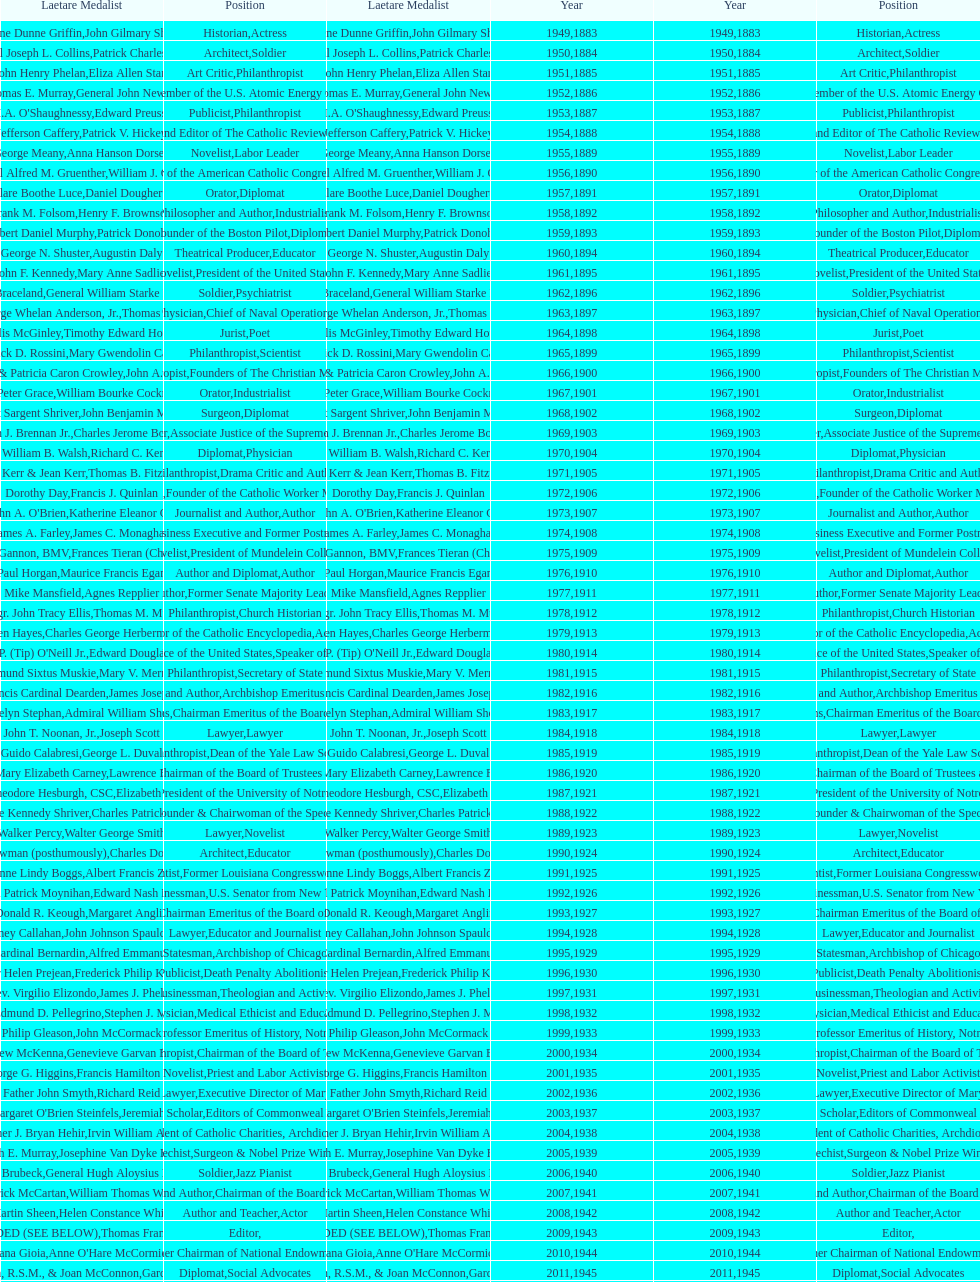Can you parse all the data within this table? {'header': ['Laetare Medalist', 'Position', 'Laetare Medalist', 'Year', 'Year', 'Position'], 'rows': [['Irene Dunne Griffin', 'Historian', 'John Gilmary Shea', '1949', '1883', 'Actress'], ['General Joseph L. Collins', 'Architect', 'Patrick Charles Keely', '1950', '1884', 'Soldier'], ['John Henry Phelan', 'Art Critic', 'Eliza Allen Starr', '1951', '1885', 'Philanthropist'], ['Thomas E. Murray', 'Engineer', 'General John Newton', '1952', '1886', 'Member of the U.S. Atomic Energy Commission'], ["I.A. O'Shaughnessy", 'Publicist', 'Edward Preuss', '1953', '1887', 'Philanthropist'], ['Jefferson Caffery', 'Founder and Editor of The Catholic Review', 'Patrick V. Hickey', '1954', '1888', 'Diplomat'], ['George Meany', 'Novelist', 'Anna Hanson Dorsey', '1955', '1889', 'Labor Leader'], ['General Alfred M. Gruenther', 'Organizer of the American Catholic Congress', 'William J. Onahan', '1956', '1890', 'Soldier'], ['Clare Boothe Luce', 'Orator', 'Daniel Dougherty', '1957', '1891', 'Diplomat'], ['Frank M. Folsom', 'Philosopher and Author', 'Henry F. Brownson', '1958', '1892', 'Industrialist'], ['Robert Daniel Murphy', 'Founder of the Boston Pilot', 'Patrick Donohue', '1959', '1893', 'Diplomat'], ['George N. Shuster', 'Theatrical Producer', 'Augustin Daly', '1960', '1894', 'Educator'], ['John F. Kennedy', 'Novelist', 'Mary Anne Sadlier', '1961', '1895', 'President of the United States'], ['Francis J. Braceland', 'Soldier', 'General William Starke Rosencrans', '1962', '1896', 'Psychiatrist'], ['Admiral George Whelan Anderson, Jr.', 'Physician', 'Thomas Addis Emmet', '1963', '1897', 'Chief of Naval Operations'], ['Phyllis McGinley', 'Jurist', 'Timothy Edward Howard', '1964', '1898', 'Poet'], ['Frederick D. Rossini', 'Philanthropist', 'Mary Gwendolin Caldwell', '1965', '1899', 'Scientist'], ['Patrick F. & Patricia Caron Crowley', 'Philanthropist', 'John A. Creighton', '1966', '1900', 'Founders of The Christian Movement'], ['J. Peter Grace', 'Orator', 'William Bourke Cockran', '1967', '1901', 'Industrialist'], ['Robert Sargent Shriver', 'Surgeon', 'John Benjamin Murphy', '1968', '1902', 'Diplomat'], ['William J. Brennan Jr.', 'Lawyer', 'Charles Jerome Bonaparte', '1969', '1903', 'Associate Justice of the Supreme Court'], ['Dr. William B. Walsh', 'Diplomat', 'Richard C. Kerens', '1970', '1904', 'Physician'], ['Walter Kerr & Jean Kerr', 'Philanthropist', 'Thomas B. Fitzpatrick', '1971', '1905', 'Drama Critic and Author'], ['Dorothy Day', 'Physician', 'Francis J. Quinlan', '1972', '1906', 'Founder of the Catholic Worker Movement'], ["Rev. John A. O'Brien", 'Journalist and Author', 'Katherine Eleanor Conway', '1973', '1907', 'Author'], ['James A. Farley', 'Economist', 'James C. Monaghan', '1974', '1908', 'Business Executive and Former Postmaster General'], ['Sr. Ann Ida Gannon, BMV', 'Novelist', 'Frances Tieran (Christian Reid)', '1975', '1909', 'President of Mundelein College'], ['Paul Horgan', 'Author and Diplomat', 'Maurice Francis Egan', '1976', '1910', 'Author'], ['Mike Mansfield', 'Author', 'Agnes Repplier', '1977', '1911', 'Former Senate Majority Leader'], ['Msgr. John Tracy Ellis', 'Philanthropist', 'Thomas M. Mulry', '1978', '1912', 'Church Historian'], ['Helen Hayes', 'Editor of the Catholic Encyclopedia', 'Charles George Herbermann', '1979', '1913', 'Actress'], ["Thomas P. (Tip) O'Neill Jr.", 'Chief Justice of the United States', 'Edward Douglass White', '1980', '1914', 'Speaker of the House'], ['Edmund Sixtus Muskie', 'Philanthropist', 'Mary V. Merrick', '1981', '1915', 'Secretary of State'], ['John Francis Cardinal Dearden', 'Physician and Author', 'James Joseph Walsh', '1982', '1916', 'Archbishop Emeritus of Detroit'], ['Edmund & Evelyn Stephan', 'Chief of Naval Operations', 'Admiral William Shepherd Benson', '1983', '1917', 'Chairman Emeritus of the Board of Trustees and his wife'], ['John T. Noonan, Jr.', 'Lawyer', 'Joseph Scott', '1984', '1918', 'Lawyer'], ['Guido Calabresi', 'Philanthropist', 'George L. Duval', '1985', '1919', 'Dean of the Yale Law School'], ['Thomas & Mary Elizabeth Carney', 'Physician', 'Lawrence Francis Flick', '1986', '1920', 'Chairman of the Board of Trustees and his wife'], ['Rev. Theodore Hesburgh, CSC', 'Artist', 'Elizabeth Nourse', '1987', '1921', 'President of the University of Notre Dame'], ['Eunice Kennedy Shriver', 'Economist', 'Charles Patrick Neill', '1988', '1922', 'Founder & Chairwoman of the Special Olympics'], ['Walker Percy', 'Lawyer', 'Walter George Smith', '1989', '1923', 'Novelist'], ['Sister Thea Bowman (posthumously)', 'Architect', 'Charles Donagh Maginnis', '1990', '1924', 'Educator'], ['Corinne Lindy Boggs', 'Scientist', 'Albert Francis Zahm', '1991', '1925', 'Former Louisiana Congresswoman'], ['Daniel Patrick Moynihan', 'Businessman', 'Edward Nash Hurley', '1992', '1926', 'U.S. Senator from New York'], ['Donald R. Keough', 'Actress', 'Margaret Anglin', '1993', '1927', 'Chairman Emeritus of the Board of Trustees'], ['Sidney Callahan', 'Lawyer', 'John Johnson Spaulding', '1994', '1928', 'Educator and Journalist'], ['Joseph Cardinal Bernardin', 'Statesman', 'Alfred Emmanuel Smith', '1995', '1929', 'Archbishop of Chicago'], ['Sister Helen Prejean', 'Publicist', 'Frederick Philip Kenkel', '1996', '1930', 'Death Penalty Abolitionist'], ['Rev. Virgilio Elizondo', 'Businessman', 'James J. Phelan', '1997', '1931', 'Theologian and Activist'], ['Dr. Edmund D. Pellegrino', 'Physician', 'Stephen J. Maher', '1998', '1932', 'Medical Ethicist and Educator'], ['Philip Gleason', 'Artist', 'John McCormack', '1999', '1933', 'Professor Emeritus of History, Notre Dame'], ['Andrew McKenna', 'Philanthropist', 'Genevieve Garvan Brady', '2000', '1934', 'Chairman of the Board of Trustees'], ['Msgr. George G. Higgins', 'Novelist', 'Francis Hamilton Spearman', '2001', '1935', 'Priest and Labor Activist'], ['Father John Smyth', 'Journalist and Lawyer', 'Richard Reid', '2002', '1936', 'Executive Director of Maryville Academy'], ["Peter and Margaret O'Brien Steinfels", 'Scholar', 'Jeremiah D. M. Ford', '2003', '1937', 'Editors of Commonweal'], ['Father J. Bryan Hehir', 'Surgeon', 'Irvin William Abell', '2004', '1938', 'President of Catholic Charities, Archdiocese of Boston'], ['Dr. Joseph E. Murray', 'Catechist', 'Josephine Van Dyke Brownson', '2005', '1939', 'Surgeon & Nobel Prize Winner'], ['Dave Brubeck', 'Soldier', 'General Hugh Aloysius Drum', '2006', '1940', 'Jazz Pianist'], ['Patrick McCartan', 'Journalist and Author', 'William Thomas Walsh', '2007', '1941', 'Chairman of the Board of Trustees'], ['Martin Sheen', 'Author and Teacher', 'Helen Constance White', '2008', '1942', 'Actor'], ['NOT AWARDED (SEE BELOW)', 'Editor', 'Thomas Francis Woodlock', '2009', '1943', ''], ['Dana Gioia', 'Journalist', "Anne O'Hare McCormick", '2010', '1944', 'Former Chairman of National Endowment for the Arts'], ['Sister Mary Scullion, R.S.M., & Joan McConnon', 'Diplomat', 'Gardiner Howland Shaw', '2011', '1945', 'Social Advocates'], ['Ken Hackett', 'Historian and Diplomat', 'Carlton J. H. Hayes', '2012', '1946', 'Former President of Catholic Relief Services'], ['Sister Susanne Gallagher, S.P.\\nSister Mary Therese Harrington, S.H.\\nRev. James H. McCarthy', 'Publisher and Civic Leader', 'William G. Bruce', '2013', '1947', 'Founders of S.P.R.E.D. (Special Religious Education Development Network)'], ['Kenneth R. Miller', 'Postmaster General and Civic Leader', 'Frank C. Walker', '2014', '1948', 'Professor of Biology at Brown University']]} How many times does philanthropist appear in the position column on this chart? 9. 